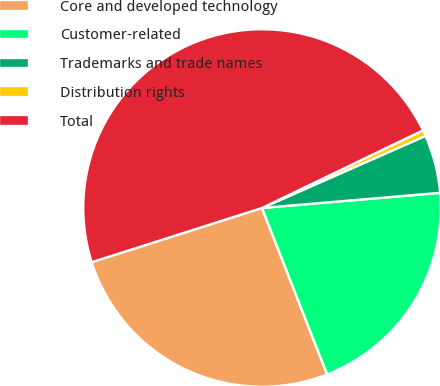Convert chart to OTSL. <chart><loc_0><loc_0><loc_500><loc_500><pie_chart><fcel>Core and developed technology<fcel>Customer-related<fcel>Trademarks and trade names<fcel>Distribution rights<fcel>Total<nl><fcel>26.03%<fcel>20.41%<fcel>5.26%<fcel>0.54%<fcel>47.75%<nl></chart> 